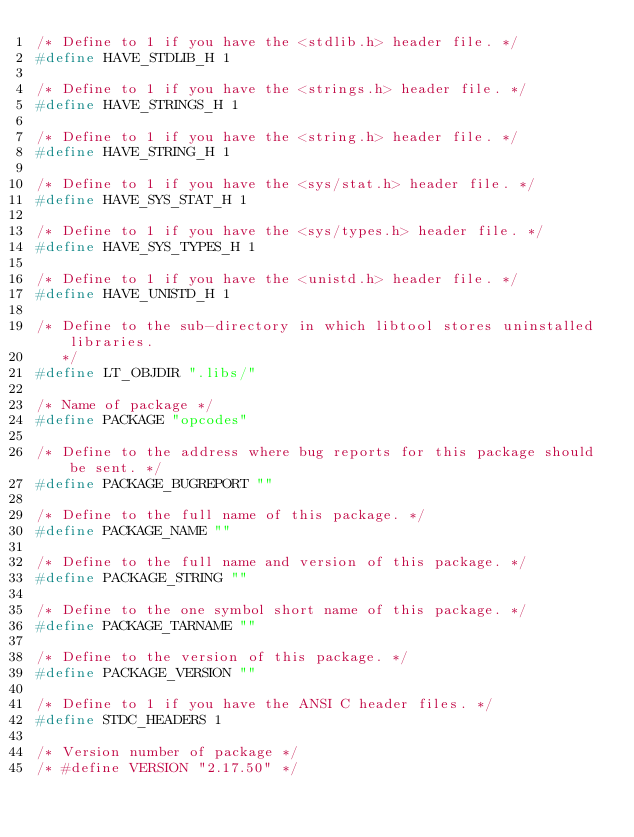<code> <loc_0><loc_0><loc_500><loc_500><_C_>/* Define to 1 if you have the <stdlib.h> header file. */
#define HAVE_STDLIB_H 1

/* Define to 1 if you have the <strings.h> header file. */
#define HAVE_STRINGS_H 1

/* Define to 1 if you have the <string.h> header file. */
#define HAVE_STRING_H 1

/* Define to 1 if you have the <sys/stat.h> header file. */
#define HAVE_SYS_STAT_H 1

/* Define to 1 if you have the <sys/types.h> header file. */
#define HAVE_SYS_TYPES_H 1

/* Define to 1 if you have the <unistd.h> header file. */
#define HAVE_UNISTD_H 1

/* Define to the sub-directory in which libtool stores uninstalled libraries.
   */
#define LT_OBJDIR ".libs/"

/* Name of package */
#define PACKAGE "opcodes"

/* Define to the address where bug reports for this package should be sent. */
#define PACKAGE_BUGREPORT ""

/* Define to the full name of this package. */
#define PACKAGE_NAME ""

/* Define to the full name and version of this package. */
#define PACKAGE_STRING ""

/* Define to the one symbol short name of this package. */
#define PACKAGE_TARNAME ""

/* Define to the version of this package. */
#define PACKAGE_VERSION ""

/* Define to 1 if you have the ANSI C header files. */
#define STDC_HEADERS 1

/* Version number of package */
/* #define VERSION "2.17.50" */
</code> 